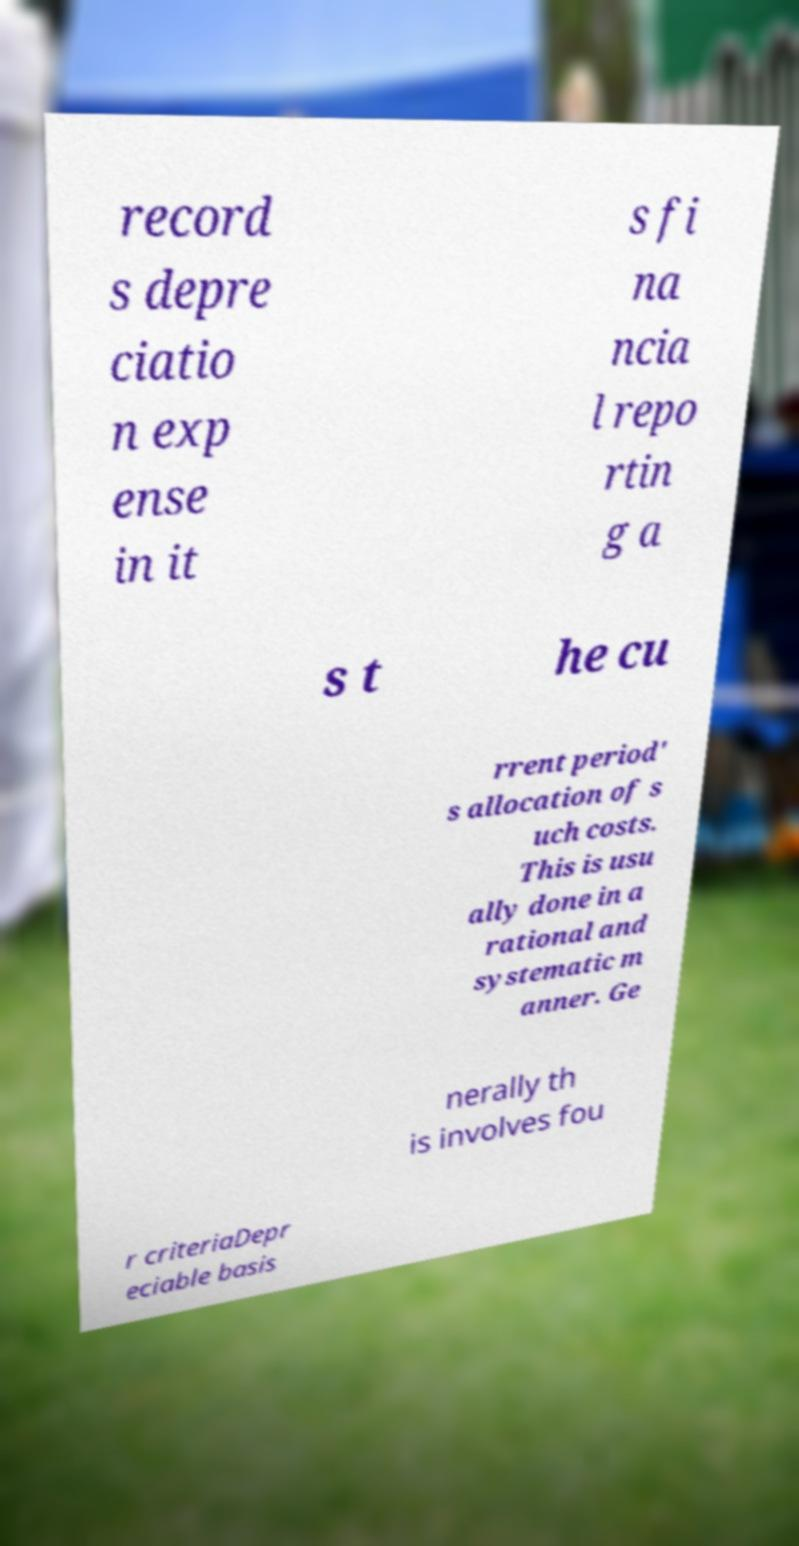What messages or text are displayed in this image? I need them in a readable, typed format. record s depre ciatio n exp ense in it s fi na ncia l repo rtin g a s t he cu rrent period' s allocation of s uch costs. This is usu ally done in a rational and systematic m anner. Ge nerally th is involves fou r criteriaDepr eciable basis 